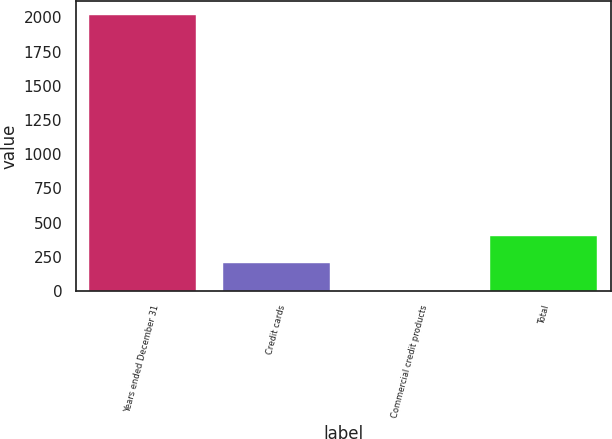<chart> <loc_0><loc_0><loc_500><loc_500><bar_chart><fcel>Years ended December 31<fcel>Credit cards<fcel>Commercial credit products<fcel>Total<nl><fcel>2016<fcel>202.5<fcel>1<fcel>404<nl></chart> 